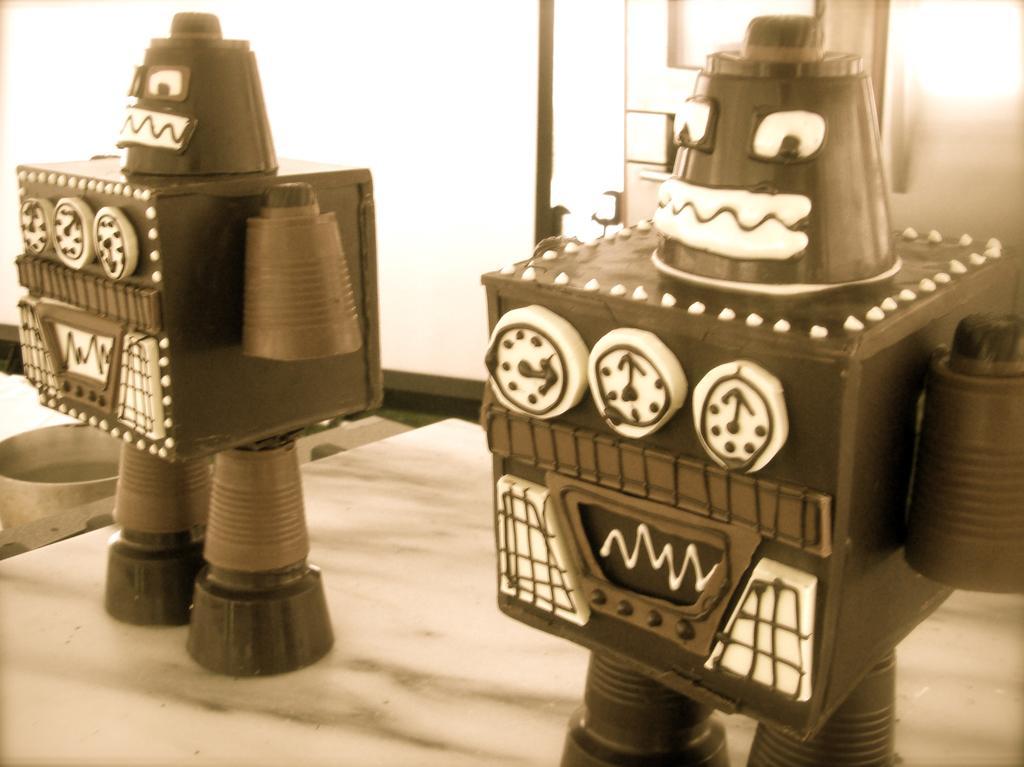Could you give a brief overview of what you see in this image? It is the black and white image in which we can see that there are two robot toys on the floor. In the left side bottom there is a small bowl. In the background it seems like a door. 